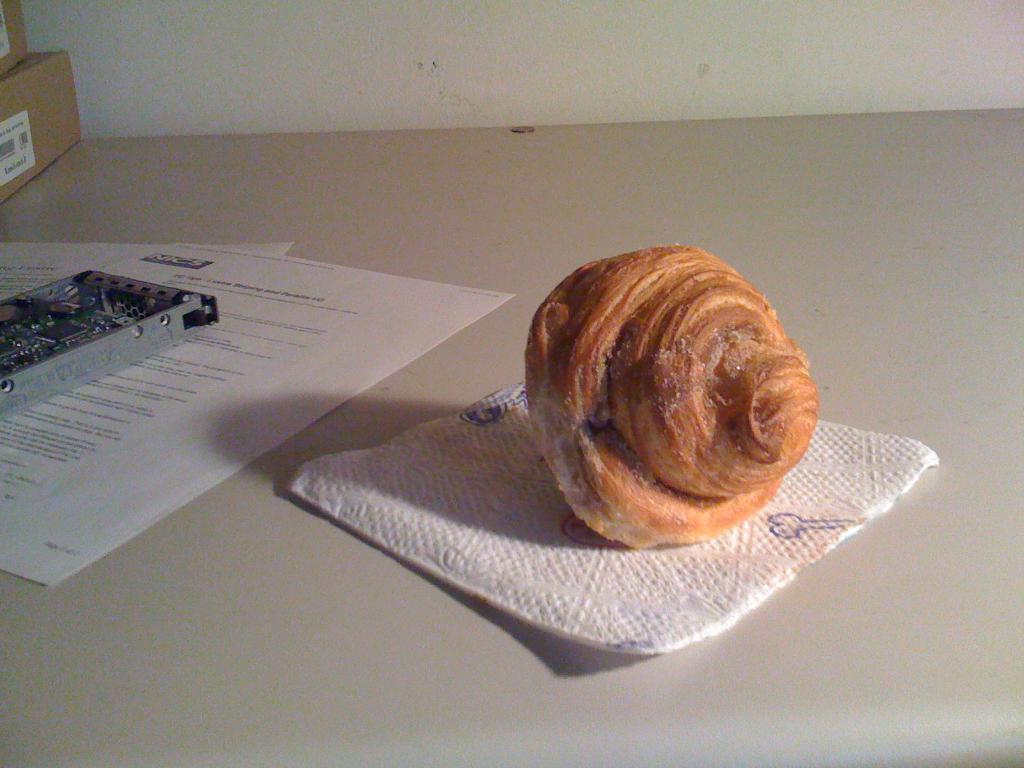Please provide a concise description of this image. Here I can see a table on which a food item, some papers, two card boxes and a metal object are placed. At the top there is a wall. 